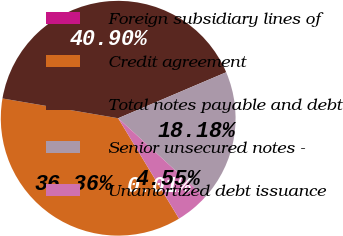Convert chart. <chart><loc_0><loc_0><loc_500><loc_500><pie_chart><fcel>Foreign subsidiary lines of<fcel>Credit agreement<fcel>Total notes payable and debt<fcel>Senior unsecured notes -<fcel>Unamortized debt issuance<nl><fcel>0.01%<fcel>36.36%<fcel>40.9%<fcel>18.18%<fcel>4.55%<nl></chart> 